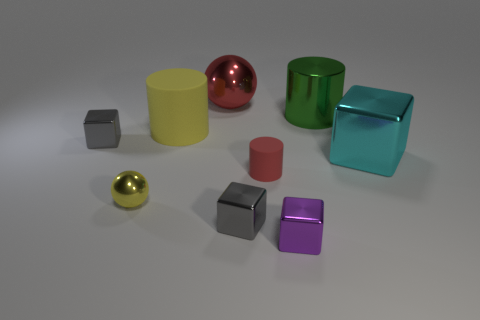Add 1 tiny gray metal objects. How many objects exist? 10 Subtract all brown spheres. How many gray blocks are left? 2 Subtract all cyan blocks. How many blocks are left? 3 Subtract all cyan cubes. How many cubes are left? 3 Subtract all spheres. How many objects are left? 7 Subtract all gray cylinders. Subtract all gray balls. How many cylinders are left? 3 Subtract 0 gray spheres. How many objects are left? 9 Subtract all yellow cylinders. Subtract all big shiny cylinders. How many objects are left? 7 Add 9 large yellow rubber things. How many large yellow rubber things are left? 10 Add 1 big yellow rubber things. How many big yellow rubber things exist? 2 